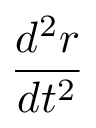<formula> <loc_0><loc_0><loc_500><loc_500>\frac { d ^ { 2 } { r } } { d t ^ { 2 } }</formula> 